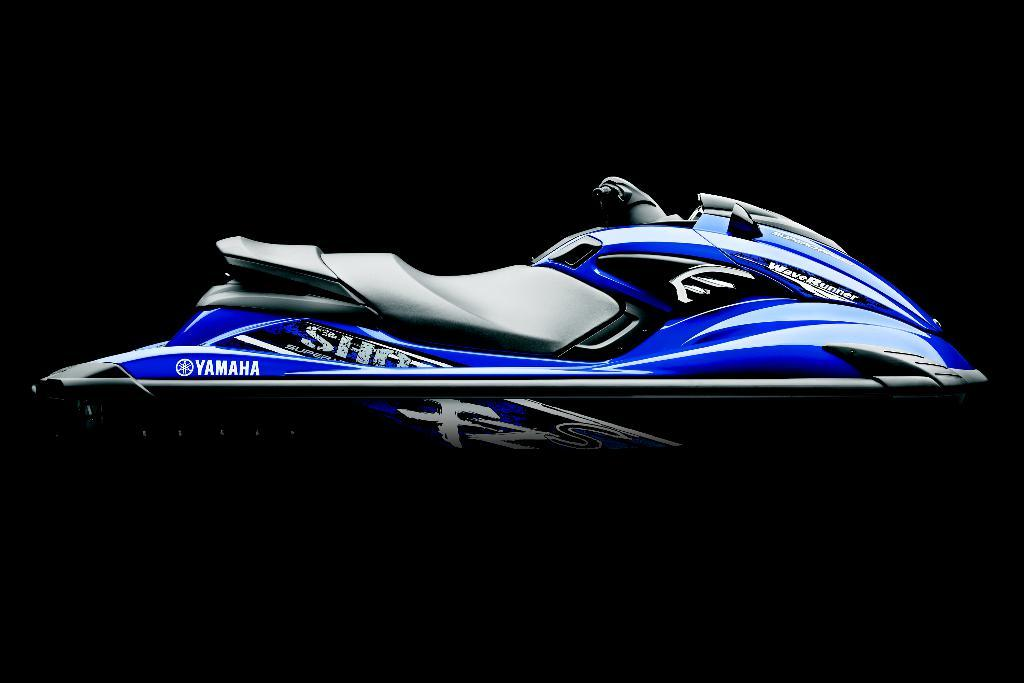What is the main subject of the image? The main subject of the image is a jet ski. Are there any words or letters on the jet ski? Yes, there is text on the jet ski. What can be observed about the overall lighting or color of the image? The background of the image is dark. Can you see a frog sitting on the jet ski in the image? No, there is no frog present on the jet ski in the image. Is there a badge attached to the jet ski in the image? There is no mention of a badge in the provided facts, so we cannot determine if one is present. 